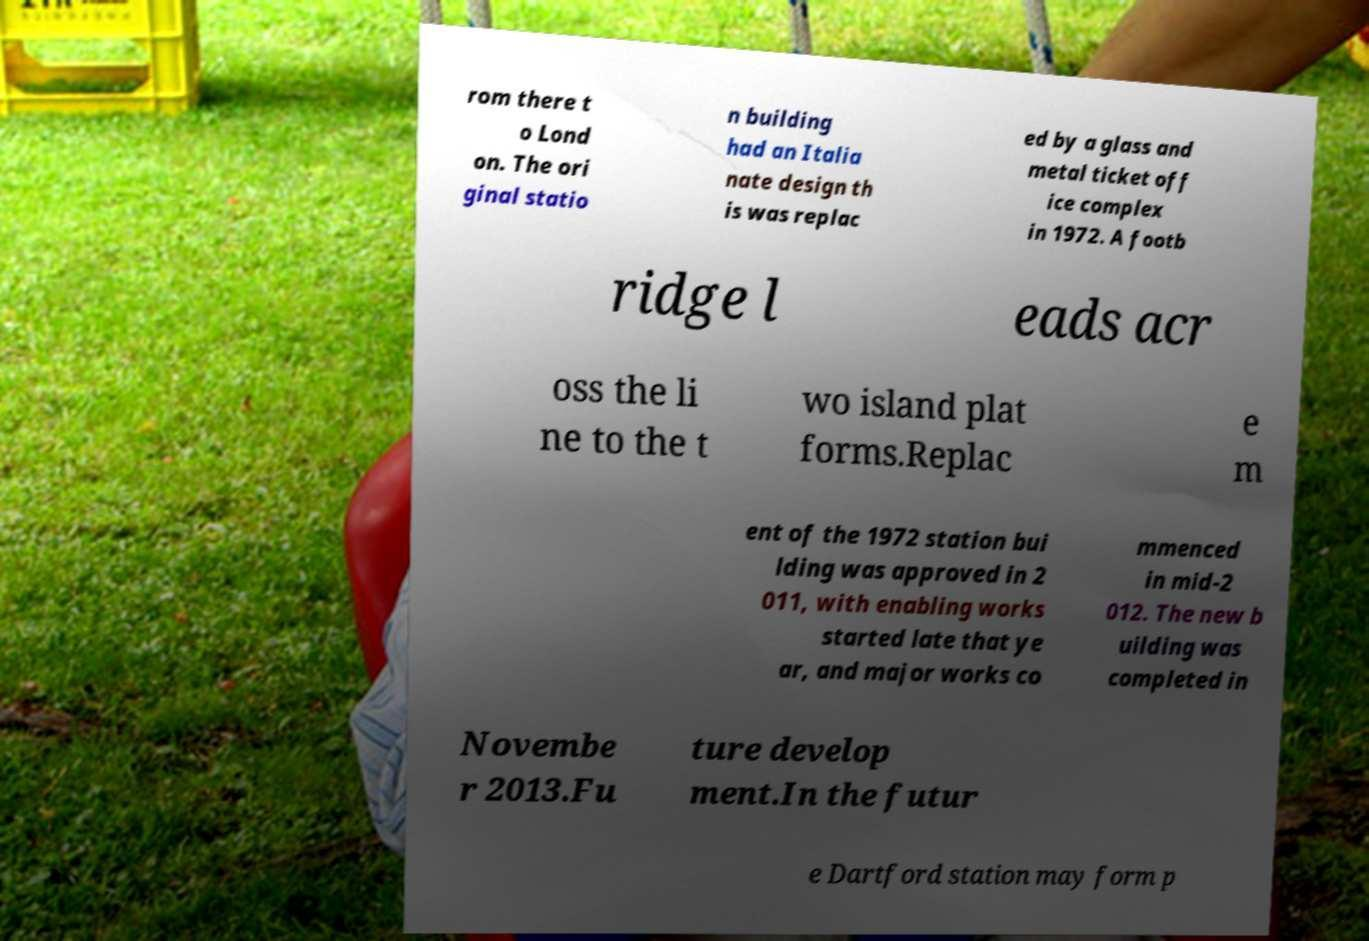I need the written content from this picture converted into text. Can you do that? rom there t o Lond on. The ori ginal statio n building had an Italia nate design th is was replac ed by a glass and metal ticket off ice complex in 1972. A footb ridge l eads acr oss the li ne to the t wo island plat forms.Replac e m ent of the 1972 station bui lding was approved in 2 011, with enabling works started late that ye ar, and major works co mmenced in mid-2 012. The new b uilding was completed in Novembe r 2013.Fu ture develop ment.In the futur e Dartford station may form p 